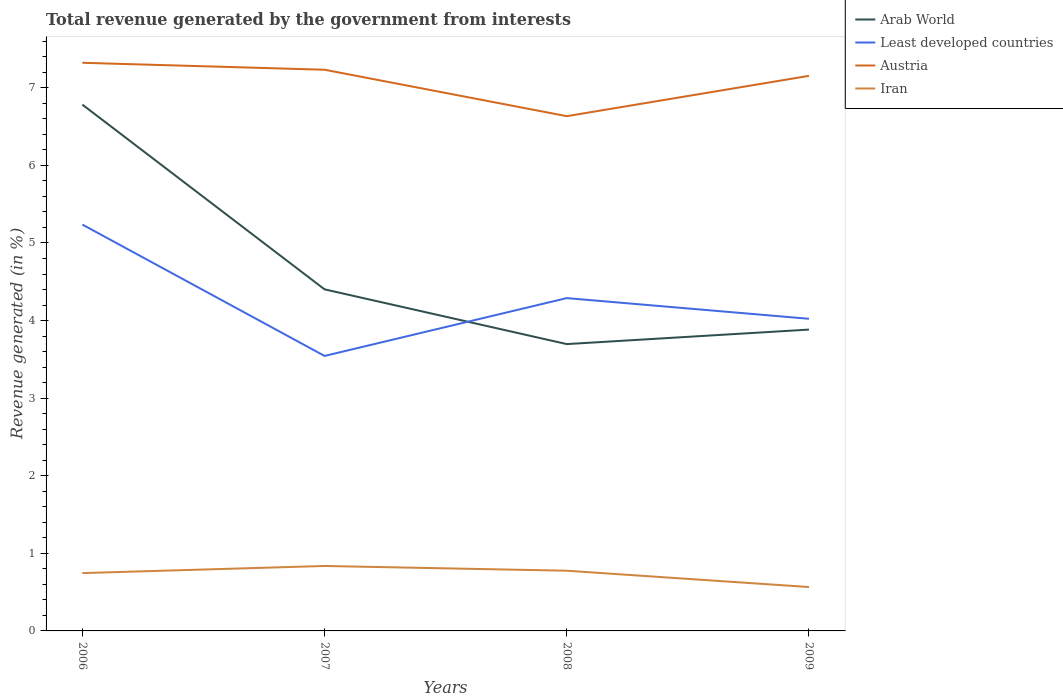How many different coloured lines are there?
Ensure brevity in your answer.  4. Does the line corresponding to Iran intersect with the line corresponding to Austria?
Your response must be concise. No. Across all years, what is the maximum total revenue generated in Iran?
Ensure brevity in your answer.  0.57. What is the total total revenue generated in Least developed countries in the graph?
Your answer should be compact. 0.95. What is the difference between the highest and the second highest total revenue generated in Arab World?
Give a very brief answer. 3.09. What is the difference between the highest and the lowest total revenue generated in Least developed countries?
Provide a succinct answer. 2. Is the total revenue generated in Least developed countries strictly greater than the total revenue generated in Arab World over the years?
Your answer should be very brief. No. Does the graph contain any zero values?
Ensure brevity in your answer.  No. Does the graph contain grids?
Your answer should be compact. No. Where does the legend appear in the graph?
Offer a terse response. Top right. What is the title of the graph?
Your answer should be very brief. Total revenue generated by the government from interests. What is the label or title of the X-axis?
Offer a terse response. Years. What is the label or title of the Y-axis?
Offer a terse response. Revenue generated (in %). What is the Revenue generated (in %) of Arab World in 2006?
Give a very brief answer. 6.78. What is the Revenue generated (in %) in Least developed countries in 2006?
Your answer should be compact. 5.24. What is the Revenue generated (in %) of Austria in 2006?
Ensure brevity in your answer.  7.32. What is the Revenue generated (in %) of Iran in 2006?
Provide a short and direct response. 0.75. What is the Revenue generated (in %) of Arab World in 2007?
Your answer should be very brief. 4.4. What is the Revenue generated (in %) of Least developed countries in 2007?
Offer a very short reply. 3.54. What is the Revenue generated (in %) of Austria in 2007?
Your answer should be very brief. 7.23. What is the Revenue generated (in %) of Iran in 2007?
Give a very brief answer. 0.84. What is the Revenue generated (in %) in Arab World in 2008?
Make the answer very short. 3.7. What is the Revenue generated (in %) of Least developed countries in 2008?
Ensure brevity in your answer.  4.29. What is the Revenue generated (in %) in Austria in 2008?
Your response must be concise. 6.63. What is the Revenue generated (in %) of Iran in 2008?
Your answer should be compact. 0.78. What is the Revenue generated (in %) in Arab World in 2009?
Your response must be concise. 3.88. What is the Revenue generated (in %) in Least developed countries in 2009?
Your answer should be very brief. 4.02. What is the Revenue generated (in %) in Austria in 2009?
Offer a terse response. 7.15. What is the Revenue generated (in %) of Iran in 2009?
Make the answer very short. 0.57. Across all years, what is the maximum Revenue generated (in %) of Arab World?
Ensure brevity in your answer.  6.78. Across all years, what is the maximum Revenue generated (in %) in Least developed countries?
Offer a very short reply. 5.24. Across all years, what is the maximum Revenue generated (in %) of Austria?
Provide a short and direct response. 7.32. Across all years, what is the maximum Revenue generated (in %) in Iran?
Keep it short and to the point. 0.84. Across all years, what is the minimum Revenue generated (in %) in Arab World?
Provide a short and direct response. 3.7. Across all years, what is the minimum Revenue generated (in %) in Least developed countries?
Make the answer very short. 3.54. Across all years, what is the minimum Revenue generated (in %) in Austria?
Keep it short and to the point. 6.63. Across all years, what is the minimum Revenue generated (in %) in Iran?
Keep it short and to the point. 0.57. What is the total Revenue generated (in %) of Arab World in the graph?
Offer a terse response. 18.77. What is the total Revenue generated (in %) of Least developed countries in the graph?
Provide a succinct answer. 17.09. What is the total Revenue generated (in %) in Austria in the graph?
Your answer should be very brief. 28.34. What is the total Revenue generated (in %) of Iran in the graph?
Provide a short and direct response. 2.92. What is the difference between the Revenue generated (in %) in Arab World in 2006 and that in 2007?
Ensure brevity in your answer.  2.38. What is the difference between the Revenue generated (in %) of Least developed countries in 2006 and that in 2007?
Offer a terse response. 1.69. What is the difference between the Revenue generated (in %) in Austria in 2006 and that in 2007?
Your answer should be very brief. 0.09. What is the difference between the Revenue generated (in %) of Iran in 2006 and that in 2007?
Your answer should be compact. -0.09. What is the difference between the Revenue generated (in %) of Arab World in 2006 and that in 2008?
Your answer should be very brief. 3.09. What is the difference between the Revenue generated (in %) in Least developed countries in 2006 and that in 2008?
Offer a terse response. 0.95. What is the difference between the Revenue generated (in %) in Austria in 2006 and that in 2008?
Provide a short and direct response. 0.69. What is the difference between the Revenue generated (in %) in Iran in 2006 and that in 2008?
Ensure brevity in your answer.  -0.03. What is the difference between the Revenue generated (in %) in Arab World in 2006 and that in 2009?
Make the answer very short. 2.9. What is the difference between the Revenue generated (in %) in Least developed countries in 2006 and that in 2009?
Your answer should be compact. 1.21. What is the difference between the Revenue generated (in %) of Austria in 2006 and that in 2009?
Your response must be concise. 0.17. What is the difference between the Revenue generated (in %) of Iran in 2006 and that in 2009?
Your answer should be compact. 0.18. What is the difference between the Revenue generated (in %) of Arab World in 2007 and that in 2008?
Provide a succinct answer. 0.71. What is the difference between the Revenue generated (in %) of Least developed countries in 2007 and that in 2008?
Offer a very short reply. -0.75. What is the difference between the Revenue generated (in %) in Austria in 2007 and that in 2008?
Keep it short and to the point. 0.6. What is the difference between the Revenue generated (in %) of Iran in 2007 and that in 2008?
Ensure brevity in your answer.  0.06. What is the difference between the Revenue generated (in %) in Arab World in 2007 and that in 2009?
Your answer should be compact. 0.52. What is the difference between the Revenue generated (in %) of Least developed countries in 2007 and that in 2009?
Offer a terse response. -0.48. What is the difference between the Revenue generated (in %) in Austria in 2007 and that in 2009?
Offer a terse response. 0.08. What is the difference between the Revenue generated (in %) in Iran in 2007 and that in 2009?
Give a very brief answer. 0.27. What is the difference between the Revenue generated (in %) of Arab World in 2008 and that in 2009?
Provide a succinct answer. -0.19. What is the difference between the Revenue generated (in %) of Least developed countries in 2008 and that in 2009?
Offer a very short reply. 0.27. What is the difference between the Revenue generated (in %) of Austria in 2008 and that in 2009?
Your answer should be compact. -0.52. What is the difference between the Revenue generated (in %) in Iran in 2008 and that in 2009?
Your answer should be very brief. 0.21. What is the difference between the Revenue generated (in %) of Arab World in 2006 and the Revenue generated (in %) of Least developed countries in 2007?
Offer a very short reply. 3.24. What is the difference between the Revenue generated (in %) of Arab World in 2006 and the Revenue generated (in %) of Austria in 2007?
Your answer should be compact. -0.45. What is the difference between the Revenue generated (in %) in Arab World in 2006 and the Revenue generated (in %) in Iran in 2007?
Keep it short and to the point. 5.95. What is the difference between the Revenue generated (in %) of Least developed countries in 2006 and the Revenue generated (in %) of Austria in 2007?
Your response must be concise. -2. What is the difference between the Revenue generated (in %) in Least developed countries in 2006 and the Revenue generated (in %) in Iran in 2007?
Your answer should be compact. 4.4. What is the difference between the Revenue generated (in %) in Austria in 2006 and the Revenue generated (in %) in Iran in 2007?
Provide a short and direct response. 6.49. What is the difference between the Revenue generated (in %) of Arab World in 2006 and the Revenue generated (in %) of Least developed countries in 2008?
Offer a terse response. 2.49. What is the difference between the Revenue generated (in %) of Arab World in 2006 and the Revenue generated (in %) of Austria in 2008?
Make the answer very short. 0.15. What is the difference between the Revenue generated (in %) in Arab World in 2006 and the Revenue generated (in %) in Iran in 2008?
Make the answer very short. 6.01. What is the difference between the Revenue generated (in %) in Least developed countries in 2006 and the Revenue generated (in %) in Austria in 2008?
Ensure brevity in your answer.  -1.4. What is the difference between the Revenue generated (in %) in Least developed countries in 2006 and the Revenue generated (in %) in Iran in 2008?
Keep it short and to the point. 4.46. What is the difference between the Revenue generated (in %) in Austria in 2006 and the Revenue generated (in %) in Iran in 2008?
Make the answer very short. 6.55. What is the difference between the Revenue generated (in %) in Arab World in 2006 and the Revenue generated (in %) in Least developed countries in 2009?
Keep it short and to the point. 2.76. What is the difference between the Revenue generated (in %) of Arab World in 2006 and the Revenue generated (in %) of Austria in 2009?
Offer a very short reply. -0.37. What is the difference between the Revenue generated (in %) in Arab World in 2006 and the Revenue generated (in %) in Iran in 2009?
Your response must be concise. 6.22. What is the difference between the Revenue generated (in %) in Least developed countries in 2006 and the Revenue generated (in %) in Austria in 2009?
Keep it short and to the point. -1.92. What is the difference between the Revenue generated (in %) of Least developed countries in 2006 and the Revenue generated (in %) of Iran in 2009?
Offer a terse response. 4.67. What is the difference between the Revenue generated (in %) in Austria in 2006 and the Revenue generated (in %) in Iran in 2009?
Provide a short and direct response. 6.76. What is the difference between the Revenue generated (in %) of Arab World in 2007 and the Revenue generated (in %) of Least developed countries in 2008?
Your answer should be compact. 0.11. What is the difference between the Revenue generated (in %) of Arab World in 2007 and the Revenue generated (in %) of Austria in 2008?
Give a very brief answer. -2.23. What is the difference between the Revenue generated (in %) in Arab World in 2007 and the Revenue generated (in %) in Iran in 2008?
Your answer should be very brief. 3.63. What is the difference between the Revenue generated (in %) in Least developed countries in 2007 and the Revenue generated (in %) in Austria in 2008?
Give a very brief answer. -3.09. What is the difference between the Revenue generated (in %) of Least developed countries in 2007 and the Revenue generated (in %) of Iran in 2008?
Offer a very short reply. 2.77. What is the difference between the Revenue generated (in %) of Austria in 2007 and the Revenue generated (in %) of Iran in 2008?
Offer a very short reply. 6.46. What is the difference between the Revenue generated (in %) in Arab World in 2007 and the Revenue generated (in %) in Least developed countries in 2009?
Provide a succinct answer. 0.38. What is the difference between the Revenue generated (in %) of Arab World in 2007 and the Revenue generated (in %) of Austria in 2009?
Offer a very short reply. -2.75. What is the difference between the Revenue generated (in %) of Arab World in 2007 and the Revenue generated (in %) of Iran in 2009?
Offer a very short reply. 3.84. What is the difference between the Revenue generated (in %) in Least developed countries in 2007 and the Revenue generated (in %) in Austria in 2009?
Your response must be concise. -3.61. What is the difference between the Revenue generated (in %) in Least developed countries in 2007 and the Revenue generated (in %) in Iran in 2009?
Provide a short and direct response. 2.98. What is the difference between the Revenue generated (in %) in Austria in 2007 and the Revenue generated (in %) in Iran in 2009?
Make the answer very short. 6.67. What is the difference between the Revenue generated (in %) in Arab World in 2008 and the Revenue generated (in %) in Least developed countries in 2009?
Your response must be concise. -0.33. What is the difference between the Revenue generated (in %) in Arab World in 2008 and the Revenue generated (in %) in Austria in 2009?
Your response must be concise. -3.46. What is the difference between the Revenue generated (in %) in Arab World in 2008 and the Revenue generated (in %) in Iran in 2009?
Make the answer very short. 3.13. What is the difference between the Revenue generated (in %) in Least developed countries in 2008 and the Revenue generated (in %) in Austria in 2009?
Your answer should be very brief. -2.86. What is the difference between the Revenue generated (in %) in Least developed countries in 2008 and the Revenue generated (in %) in Iran in 2009?
Ensure brevity in your answer.  3.72. What is the difference between the Revenue generated (in %) in Austria in 2008 and the Revenue generated (in %) in Iran in 2009?
Offer a very short reply. 6.07. What is the average Revenue generated (in %) of Arab World per year?
Your answer should be compact. 4.69. What is the average Revenue generated (in %) in Least developed countries per year?
Your response must be concise. 4.27. What is the average Revenue generated (in %) of Austria per year?
Your answer should be compact. 7.09. What is the average Revenue generated (in %) of Iran per year?
Offer a very short reply. 0.73. In the year 2006, what is the difference between the Revenue generated (in %) of Arab World and Revenue generated (in %) of Least developed countries?
Provide a succinct answer. 1.55. In the year 2006, what is the difference between the Revenue generated (in %) of Arab World and Revenue generated (in %) of Austria?
Offer a very short reply. -0.54. In the year 2006, what is the difference between the Revenue generated (in %) in Arab World and Revenue generated (in %) in Iran?
Offer a terse response. 6.04. In the year 2006, what is the difference between the Revenue generated (in %) of Least developed countries and Revenue generated (in %) of Austria?
Ensure brevity in your answer.  -2.09. In the year 2006, what is the difference between the Revenue generated (in %) of Least developed countries and Revenue generated (in %) of Iran?
Keep it short and to the point. 4.49. In the year 2006, what is the difference between the Revenue generated (in %) in Austria and Revenue generated (in %) in Iran?
Offer a very short reply. 6.58. In the year 2007, what is the difference between the Revenue generated (in %) of Arab World and Revenue generated (in %) of Least developed countries?
Provide a short and direct response. 0.86. In the year 2007, what is the difference between the Revenue generated (in %) of Arab World and Revenue generated (in %) of Austria?
Make the answer very short. -2.83. In the year 2007, what is the difference between the Revenue generated (in %) of Arab World and Revenue generated (in %) of Iran?
Keep it short and to the point. 3.57. In the year 2007, what is the difference between the Revenue generated (in %) of Least developed countries and Revenue generated (in %) of Austria?
Offer a very short reply. -3.69. In the year 2007, what is the difference between the Revenue generated (in %) of Least developed countries and Revenue generated (in %) of Iran?
Offer a very short reply. 2.71. In the year 2007, what is the difference between the Revenue generated (in %) in Austria and Revenue generated (in %) in Iran?
Ensure brevity in your answer.  6.4. In the year 2008, what is the difference between the Revenue generated (in %) of Arab World and Revenue generated (in %) of Least developed countries?
Offer a very short reply. -0.59. In the year 2008, what is the difference between the Revenue generated (in %) of Arab World and Revenue generated (in %) of Austria?
Your answer should be very brief. -2.94. In the year 2008, what is the difference between the Revenue generated (in %) in Arab World and Revenue generated (in %) in Iran?
Give a very brief answer. 2.92. In the year 2008, what is the difference between the Revenue generated (in %) of Least developed countries and Revenue generated (in %) of Austria?
Offer a terse response. -2.35. In the year 2008, what is the difference between the Revenue generated (in %) in Least developed countries and Revenue generated (in %) in Iran?
Your answer should be compact. 3.51. In the year 2008, what is the difference between the Revenue generated (in %) of Austria and Revenue generated (in %) of Iran?
Keep it short and to the point. 5.86. In the year 2009, what is the difference between the Revenue generated (in %) in Arab World and Revenue generated (in %) in Least developed countries?
Make the answer very short. -0.14. In the year 2009, what is the difference between the Revenue generated (in %) in Arab World and Revenue generated (in %) in Austria?
Offer a terse response. -3.27. In the year 2009, what is the difference between the Revenue generated (in %) of Arab World and Revenue generated (in %) of Iran?
Provide a short and direct response. 3.32. In the year 2009, what is the difference between the Revenue generated (in %) in Least developed countries and Revenue generated (in %) in Austria?
Give a very brief answer. -3.13. In the year 2009, what is the difference between the Revenue generated (in %) in Least developed countries and Revenue generated (in %) in Iran?
Give a very brief answer. 3.46. In the year 2009, what is the difference between the Revenue generated (in %) of Austria and Revenue generated (in %) of Iran?
Make the answer very short. 6.59. What is the ratio of the Revenue generated (in %) in Arab World in 2006 to that in 2007?
Offer a very short reply. 1.54. What is the ratio of the Revenue generated (in %) in Least developed countries in 2006 to that in 2007?
Ensure brevity in your answer.  1.48. What is the ratio of the Revenue generated (in %) in Austria in 2006 to that in 2007?
Make the answer very short. 1.01. What is the ratio of the Revenue generated (in %) in Iran in 2006 to that in 2007?
Make the answer very short. 0.89. What is the ratio of the Revenue generated (in %) in Arab World in 2006 to that in 2008?
Give a very brief answer. 1.83. What is the ratio of the Revenue generated (in %) of Least developed countries in 2006 to that in 2008?
Your answer should be very brief. 1.22. What is the ratio of the Revenue generated (in %) in Austria in 2006 to that in 2008?
Ensure brevity in your answer.  1.1. What is the ratio of the Revenue generated (in %) in Iran in 2006 to that in 2008?
Your answer should be compact. 0.96. What is the ratio of the Revenue generated (in %) in Arab World in 2006 to that in 2009?
Your response must be concise. 1.75. What is the ratio of the Revenue generated (in %) in Least developed countries in 2006 to that in 2009?
Keep it short and to the point. 1.3. What is the ratio of the Revenue generated (in %) in Austria in 2006 to that in 2009?
Offer a very short reply. 1.02. What is the ratio of the Revenue generated (in %) in Iran in 2006 to that in 2009?
Make the answer very short. 1.32. What is the ratio of the Revenue generated (in %) in Arab World in 2007 to that in 2008?
Ensure brevity in your answer.  1.19. What is the ratio of the Revenue generated (in %) of Least developed countries in 2007 to that in 2008?
Your response must be concise. 0.83. What is the ratio of the Revenue generated (in %) in Austria in 2007 to that in 2008?
Your answer should be very brief. 1.09. What is the ratio of the Revenue generated (in %) of Iran in 2007 to that in 2008?
Offer a terse response. 1.08. What is the ratio of the Revenue generated (in %) in Arab World in 2007 to that in 2009?
Make the answer very short. 1.13. What is the ratio of the Revenue generated (in %) of Least developed countries in 2007 to that in 2009?
Your response must be concise. 0.88. What is the ratio of the Revenue generated (in %) in Austria in 2007 to that in 2009?
Offer a very short reply. 1.01. What is the ratio of the Revenue generated (in %) in Iran in 2007 to that in 2009?
Your answer should be very brief. 1.48. What is the ratio of the Revenue generated (in %) of Arab World in 2008 to that in 2009?
Ensure brevity in your answer.  0.95. What is the ratio of the Revenue generated (in %) in Least developed countries in 2008 to that in 2009?
Offer a very short reply. 1.07. What is the ratio of the Revenue generated (in %) of Austria in 2008 to that in 2009?
Offer a terse response. 0.93. What is the ratio of the Revenue generated (in %) in Iran in 2008 to that in 2009?
Keep it short and to the point. 1.37. What is the difference between the highest and the second highest Revenue generated (in %) in Arab World?
Ensure brevity in your answer.  2.38. What is the difference between the highest and the second highest Revenue generated (in %) of Least developed countries?
Offer a very short reply. 0.95. What is the difference between the highest and the second highest Revenue generated (in %) in Austria?
Keep it short and to the point. 0.09. What is the difference between the highest and the second highest Revenue generated (in %) in Iran?
Your response must be concise. 0.06. What is the difference between the highest and the lowest Revenue generated (in %) of Arab World?
Provide a short and direct response. 3.09. What is the difference between the highest and the lowest Revenue generated (in %) of Least developed countries?
Your answer should be compact. 1.69. What is the difference between the highest and the lowest Revenue generated (in %) in Austria?
Offer a terse response. 0.69. What is the difference between the highest and the lowest Revenue generated (in %) of Iran?
Ensure brevity in your answer.  0.27. 